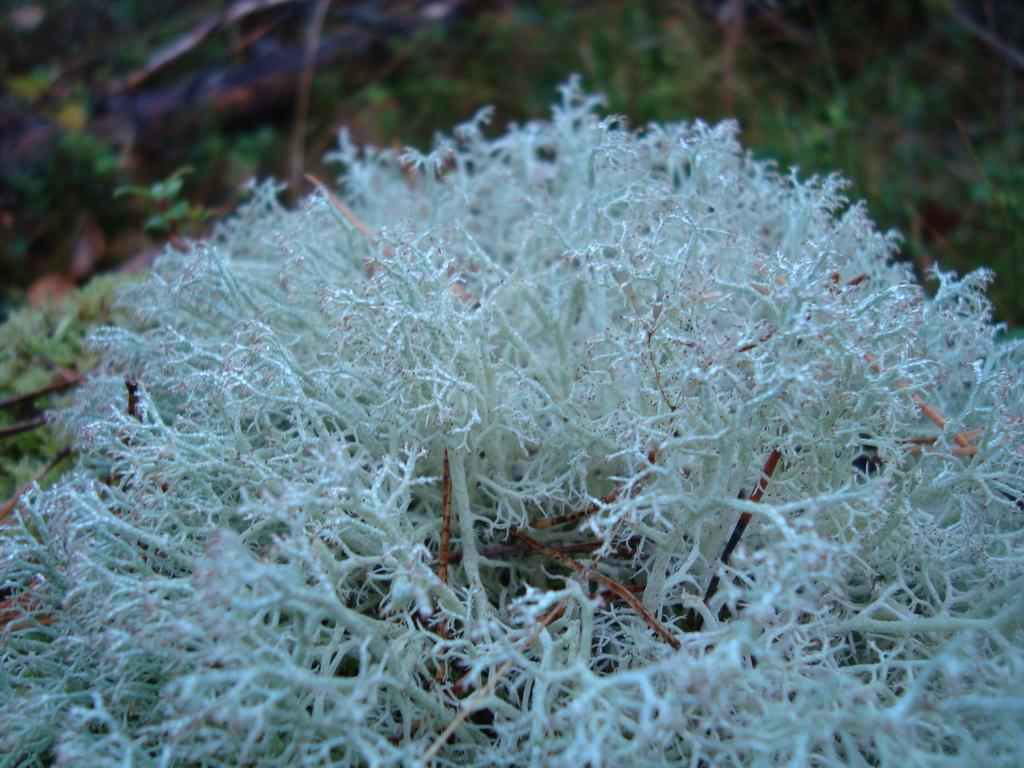What is located at the bottom of the image? There are plants at the bottom of the image. How would you describe the background of the image? The background of the image is blurry. Are there any plants visible in the background? Yes, there are plants visible in the background of the image. What direction is the machine facing in the image? There is no machine present in the image. Is the person in the image sleeping? There is no person present in the image. 